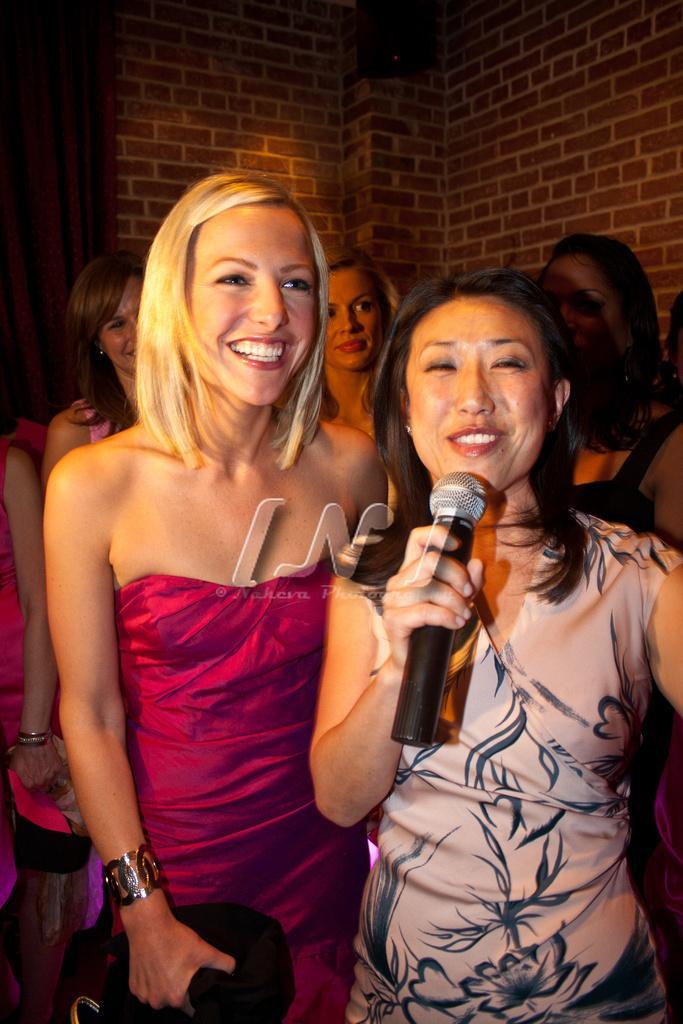How would you summarize this image in a sentence or two? There is a woman standing, she is holding a microphone and she is talking. There is a another woman at the left side and she is smiling. In the background there are three women who are standing. There is wooden wall in background. 